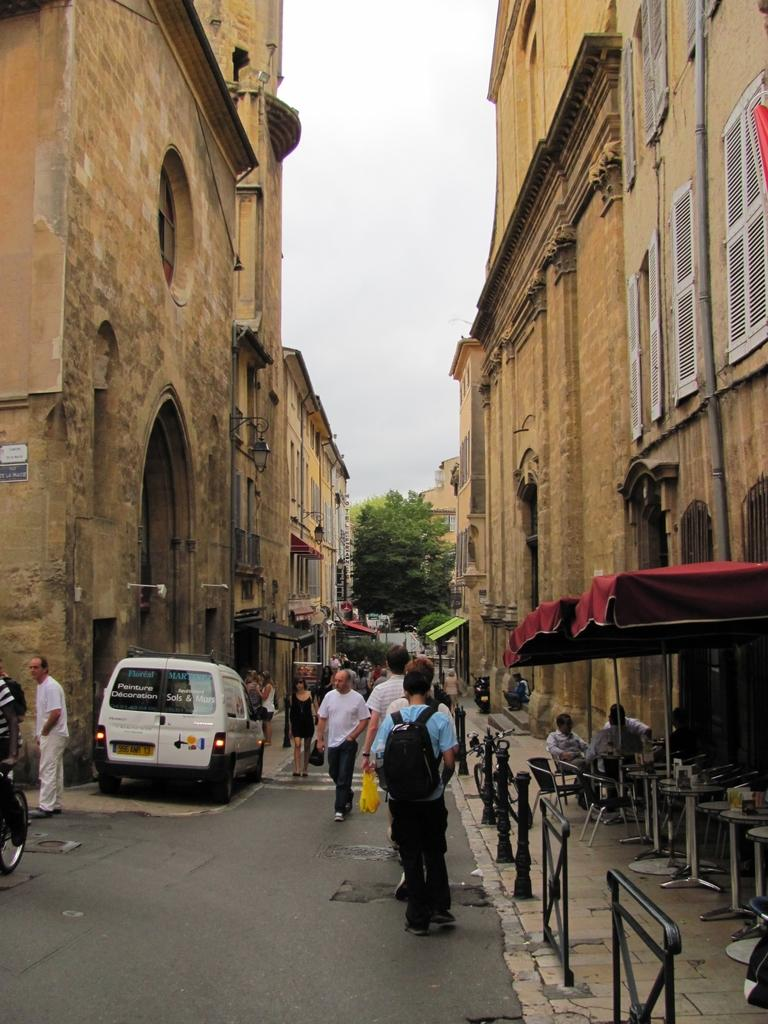How many people can be seen in the image? There are people in the image, but the exact number is not specified. What type of temporary shelters are present in the image? There are tents in the image. What objects are placed on tables in the image? There are objects on tables in the image, but their specific nature is not mentioned. What type of signage or display boards are present in the image? There are boards in the image. What type of permanent structures are present in the image? There are buildings in the image. What type of transportation is present in the image? There is a vehicle in the image. What type of vegetation is present in the image? There are trees in the image. What type of vertical supports are present in the image? There are poles in the image. What type of illumination is present in the image? There are lights in the image. What can be seen in the background of the image? The sky is visible in the background of the image. What type of horn can be heard in the image? There is no mention of any horn or sound in the image, so it cannot be determined from the image. How does the image convey a sense of respect? The image does not convey a sense of respect or any emotions; it is a visual representation of the scene described in the facts. 